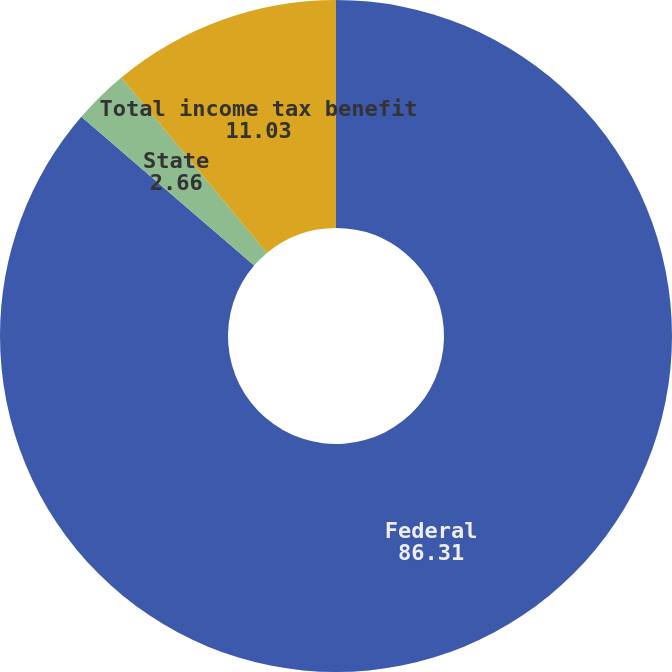Convert chart to OTSL. <chart><loc_0><loc_0><loc_500><loc_500><pie_chart><fcel>Federal<fcel>State<fcel>Total income tax benefit<nl><fcel>86.31%<fcel>2.66%<fcel>11.03%<nl></chart> 